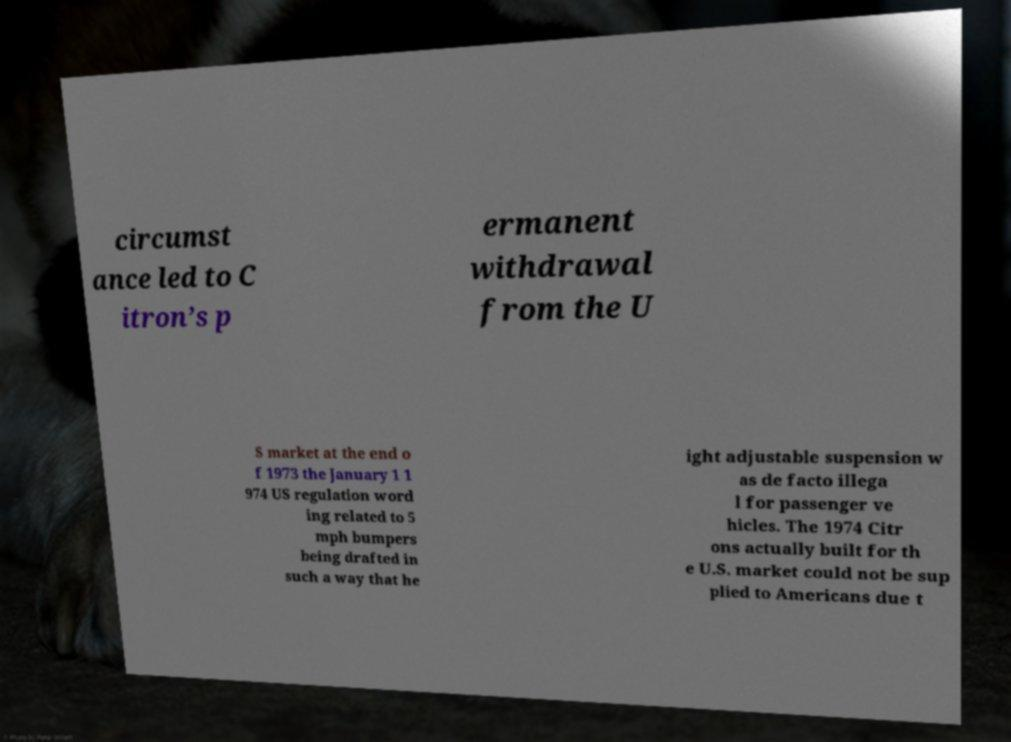Could you extract and type out the text from this image? circumst ance led to C itron’s p ermanent withdrawal from the U S market at the end o f 1973 the January 1 1 974 US regulation word ing related to 5 mph bumpers being drafted in such a way that he ight adjustable suspension w as de facto illega l for passenger ve hicles. The 1974 Citr ons actually built for th e U.S. market could not be sup plied to Americans due t 